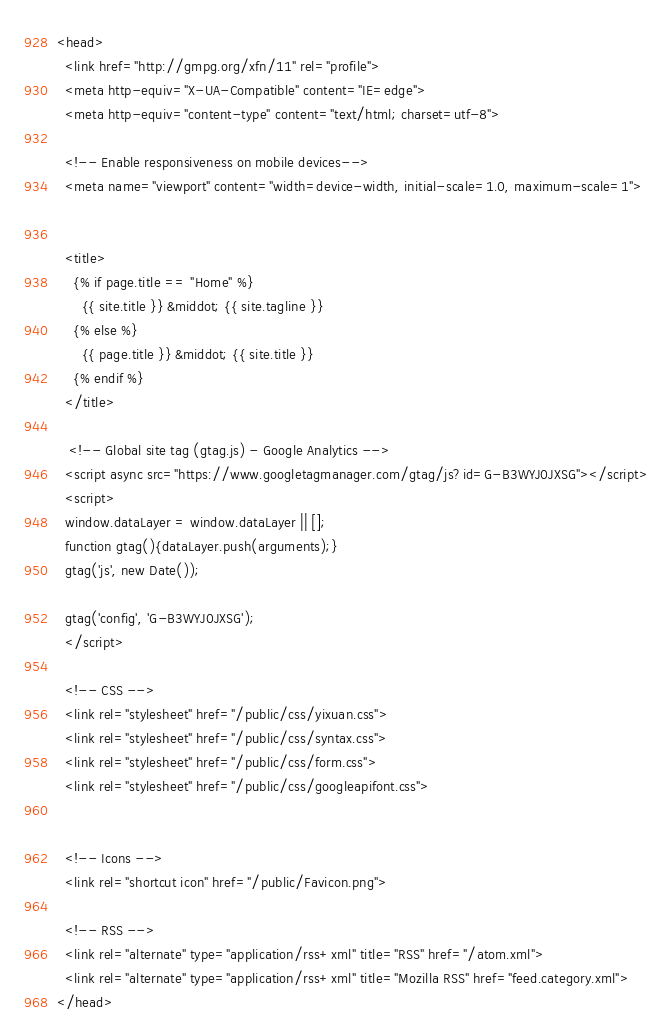Convert code to text. <code><loc_0><loc_0><loc_500><loc_500><_HTML_><head>
  <link href="http://gmpg.org/xfn/11" rel="profile">
  <meta http-equiv="X-UA-Compatible" content="IE=edge">
  <meta http-equiv="content-type" content="text/html; charset=utf-8">

  <!-- Enable responsiveness on mobile devices-->
  <meta name="viewport" content="width=device-width, initial-scale=1.0, maximum-scale=1">


  <title>
    {% if page.title == "Home" %}
      {{ site.title }} &middot; {{ site.tagline }}
    {% else %}
      {{ page.title }} &middot; {{ site.title }}
    {% endif %}
  </title>
  
   <!-- Global site tag (gtag.js) - Google Analytics -->
  <script async src="https://www.googletagmanager.com/gtag/js?id=G-B3WYJ0JXSG"></script>
  <script>
  window.dataLayer = window.dataLayer || [];
  function gtag(){dataLayer.push(arguments);}
  gtag('js', new Date());

  gtag('config', 'G-B3WYJ0JXSG');
  </script>

  <!-- CSS -->
  <link rel="stylesheet" href="/public/css/yixuan.css">
  <link rel="stylesheet" href="/public/css/syntax.css">
  <link rel="stylesheet" href="/public/css/form.css">
  <link rel="stylesheet" href="/public/css/googleapifont.css">


  <!-- Icons -->
  <link rel="shortcut icon" href="/public/Favicon.png">

  <!-- RSS -->
  <link rel="alternate" type="application/rss+xml" title="RSS" href="/atom.xml">
  <link rel="alternate" type="application/rss+xml" title="Mozilla RSS" href="feed.category.xml">
</head>
</code> 